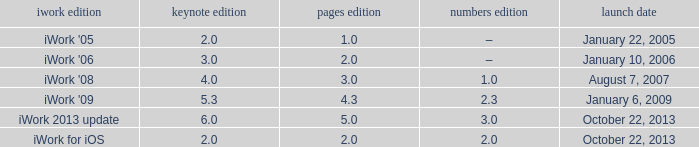What version of iWork was released on October 22, 2013 with a pages version greater than 2? Iwork 2013 update. 